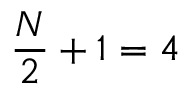Convert formula to latex. <formula><loc_0><loc_0><loc_500><loc_500>\frac { N } { 2 } + 1 = 4</formula> 